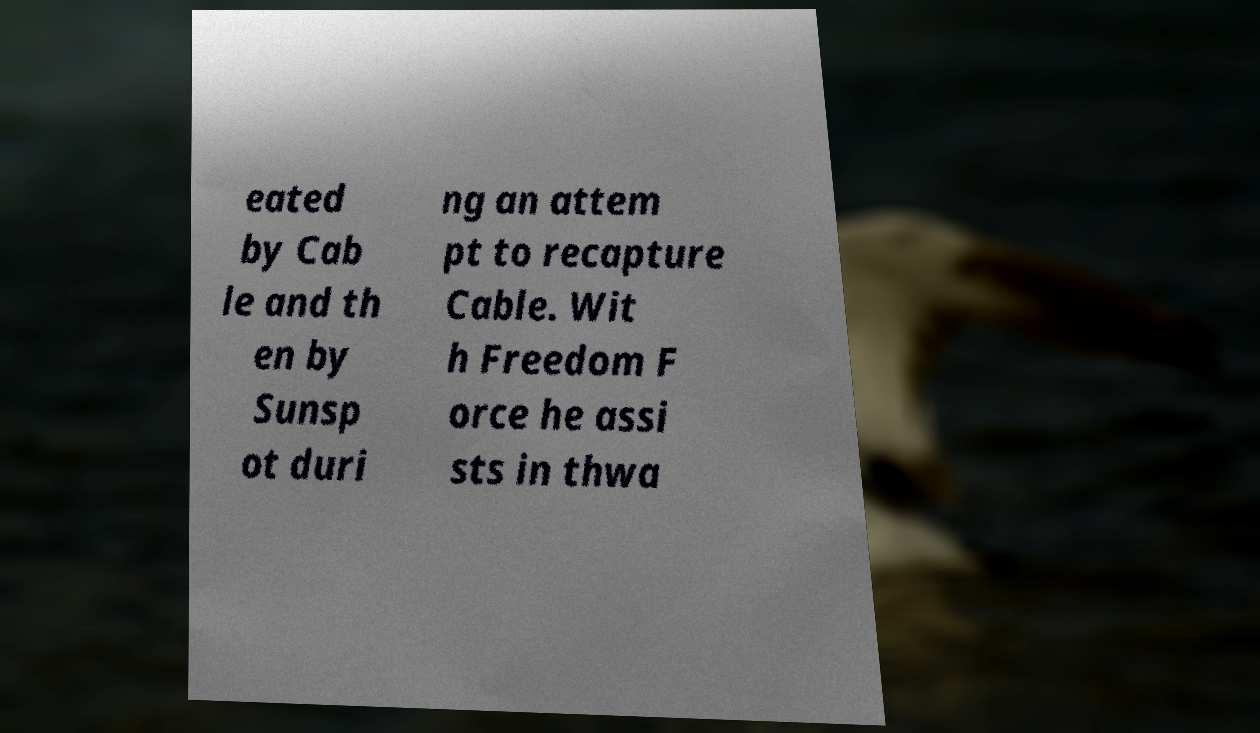Please identify and transcribe the text found in this image. eated by Cab le and th en by Sunsp ot duri ng an attem pt to recapture Cable. Wit h Freedom F orce he assi sts in thwa 